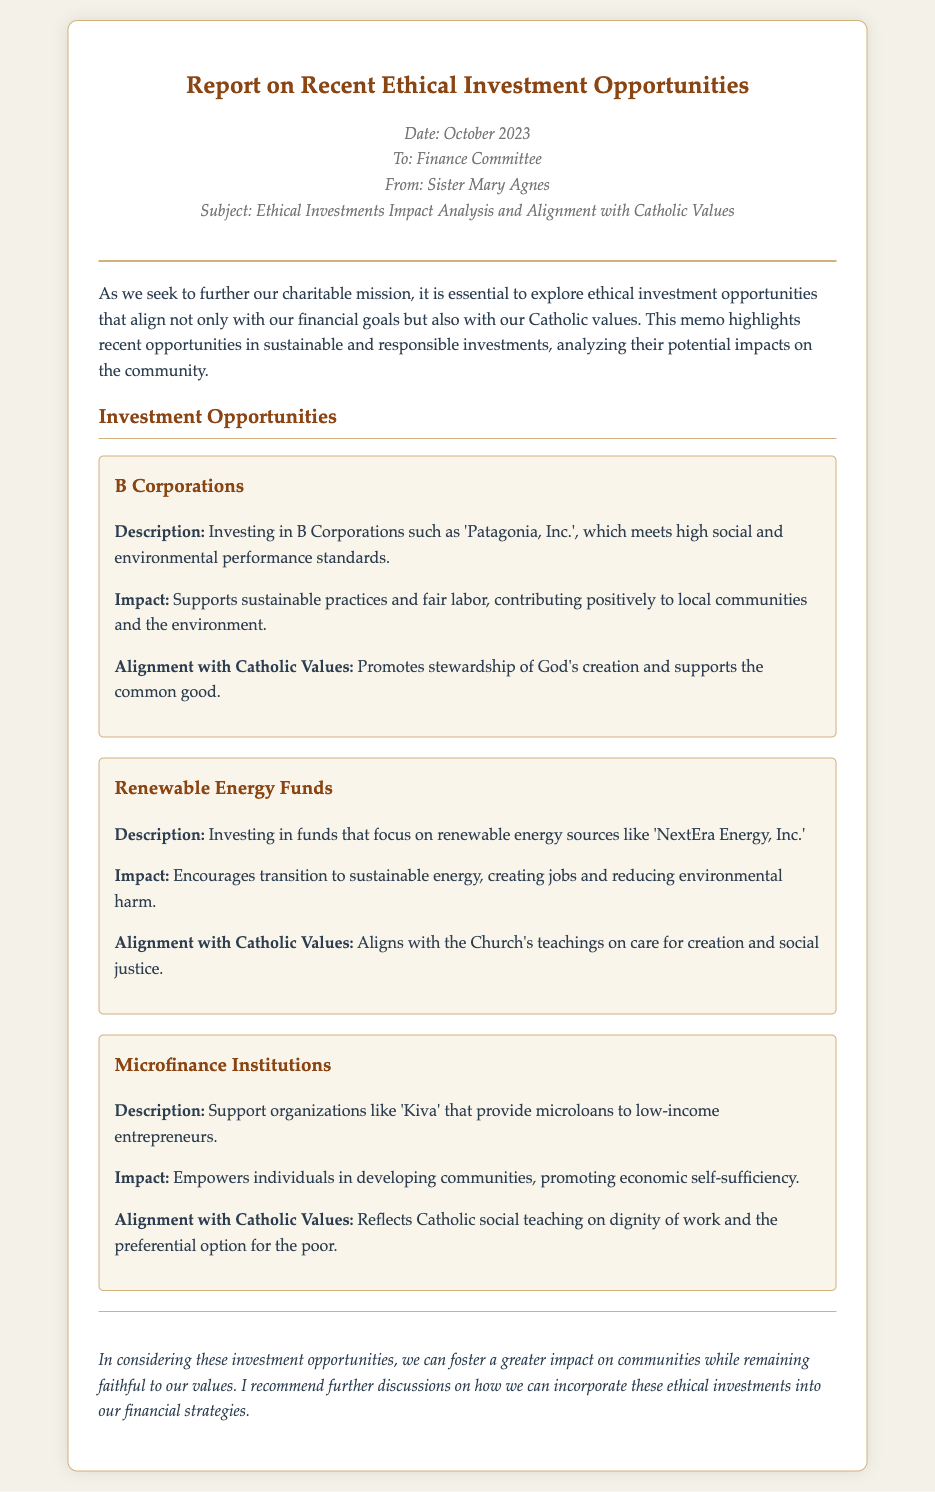What is the date of the report? The report was prepared in October 2023, as specified in the memo.
Answer: October 2023 Who is the author of the memo? The memo is authored by Sister Mary Agnes, as mentioned in the sender's details.
Answer: Sister Mary Agnes What type of investment opportunity is related to 'Patagonia, Inc.'? ‘Patagonia, Inc.’ is mentioned as a B Corporation in the investment opportunities section.
Answer: B Corporations What positive impact does investing in Renewable Energy Funds aim to achieve? The investment in renewable energy aims to encourage a transition to sustainable energy and reduce environmental harm.
Answer: Reduce environmental harm Which Catholic value does investing in Microfinance Institutions reflect? The investment reflects the Catholic social teaching on dignity of work and the preferential option for the poor.
Answer: Dignity of work How many investment opportunities are outlined in the document? The memo describes three distinct investment opportunities in detail.
Answer: Three What is the conclusion of the memo? The conclusion recommends further discussions on incorporating ethical investments into financial strategies.
Answer: Further discussions on ethical investments What does the memo emphasize about ethical investments? The memo emphasizes the importance of aligning investments with financial goals and Catholic values.
Answer: Aligning with Catholic values 